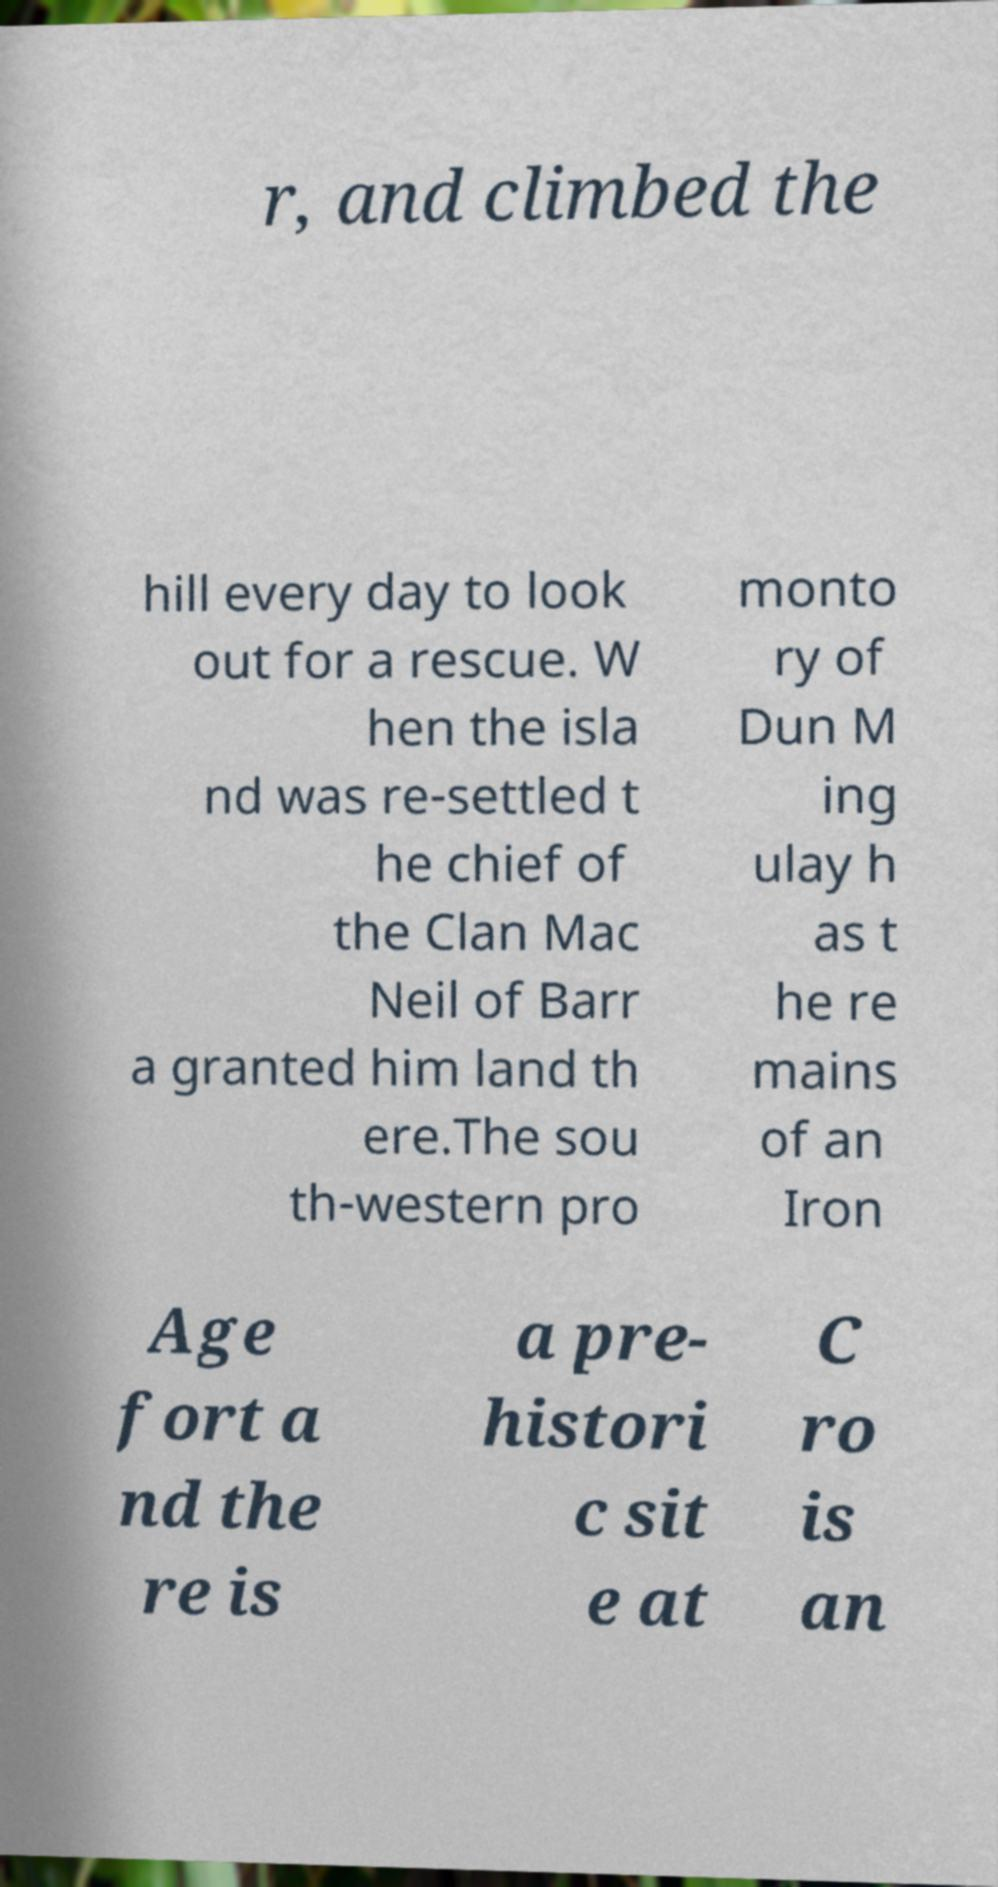What messages or text are displayed in this image? I need them in a readable, typed format. r, and climbed the hill every day to look out for a rescue. W hen the isla nd was re-settled t he chief of the Clan Mac Neil of Barr a granted him land th ere.The sou th-western pro monto ry of Dun M ing ulay h as t he re mains of an Iron Age fort a nd the re is a pre- histori c sit e at C ro is an 